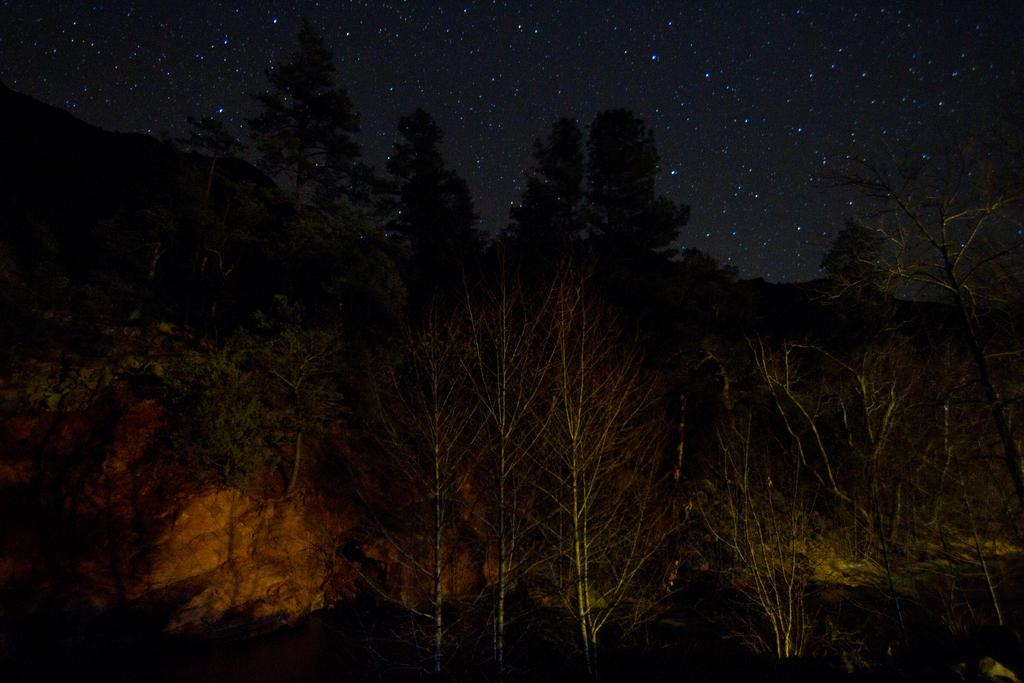What type of vegetation is present in the image? There is a group of trees in the image. What else can be seen on the ground in the image? There are rocks in the image. What is visible in the sky in the image? Stars are visible in the image. What else can be seen in the sky in the image? The sky is visible in the image. What type of dinner is being served in the image? There is no dinner present in the image; it features a group of trees, rocks, stars, and the sky. 